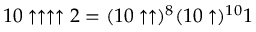Convert formula to latex. <formula><loc_0><loc_0><loc_500><loc_500>1 0 \uparrow \uparrow \uparrow \uparrow 2 = ( 1 0 \uparrow \uparrow ) ^ { 8 } ( 1 0 \uparrow ) ^ { 1 0 } 1</formula> 